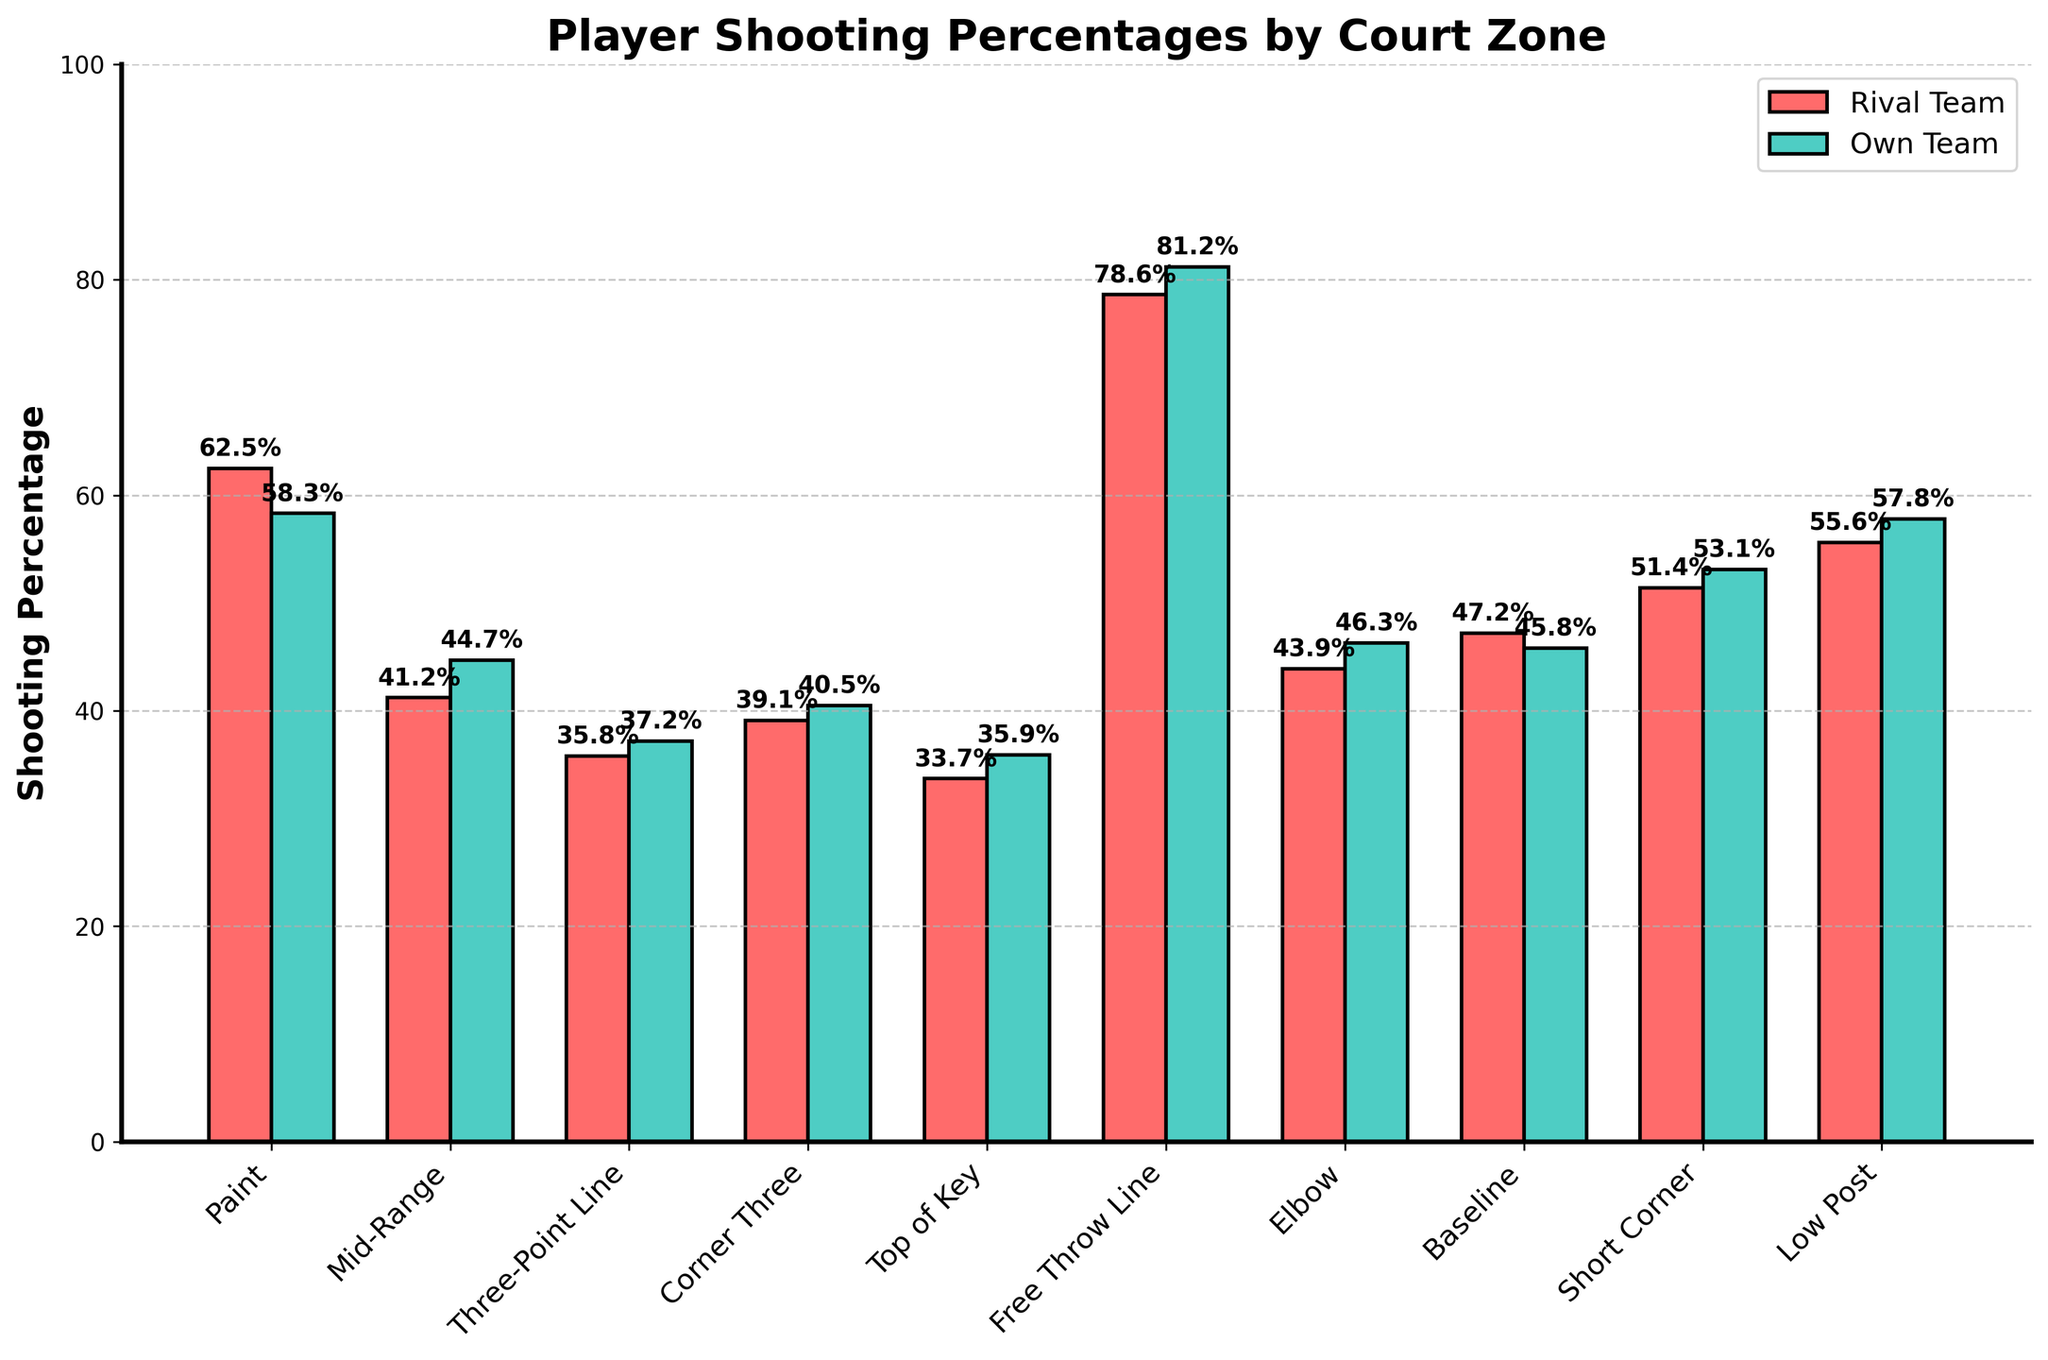Which team has a higher shooting percentage from the Paint? The bars representing the Paint zone show that the Own Team percentage bar is slightly higher than the Rival Team percentage bar.
Answer: Own Team By how much does the Own Team shoot better from the Free Throw Line compared to the Rival Team? The Own Team percentage for the Free Throw Line is 81.2%, and the Rival Team percentage is 78.6%. The difference is 81.2% - 78.6%.
Answer: 2.6% Which zone has the smallest difference in shooting percentage between the Rival Team and the Own Team? By comparing the differences between each pair of bars, we see that the Baseline zone has the smallest difference between the Rival Team (47.2%) and the Own Team (45.8%).
Answer: Baseline What is the average shooting percentage for the Own Team across all zones? The sum of the percentages for the Own Team is 58.3 + 44.7 + 37.2 + 40.5 + 35.9 + 81.2 + 46.3 + 45.8 + 53.1 + 57.8 = 500.8%. The average is 500.8 / 10.
Answer: 50.08% Which team has a lower shooting percentage from the Mid-Range zone by more than 10%? The Own Team has a shooting percentage of 44.7% in this zone, and the Rival Team has 41.2%. The difference is 44.7% - 41.2%.
Answer: Neither In which zone does the Own Team have the highest shooting percentage? The bars show that the Own Team's highest percentage is from the Free Throw Line with 81.2%.
Answer: Free Throw Line Considering both teams' percentages, from which zone is the overall shooting percentage closest to 50%? By checking all zones, the percentages closest to 50% are Baseline (45.8% for Own Team, 47.2% for Rival Team) with an average of (45.8 + 47.2) / 2 = 46.5%.
Answer: Baseline How much higher is the Rival Team's shooting percentage from the Elbow compared to the Top of Key? The Rival Team's percentage from the Elbow is 43.9% and from the Top of Key is 33.7%. The difference is 43.9% - 33.7%.
Answer: 10.2% 